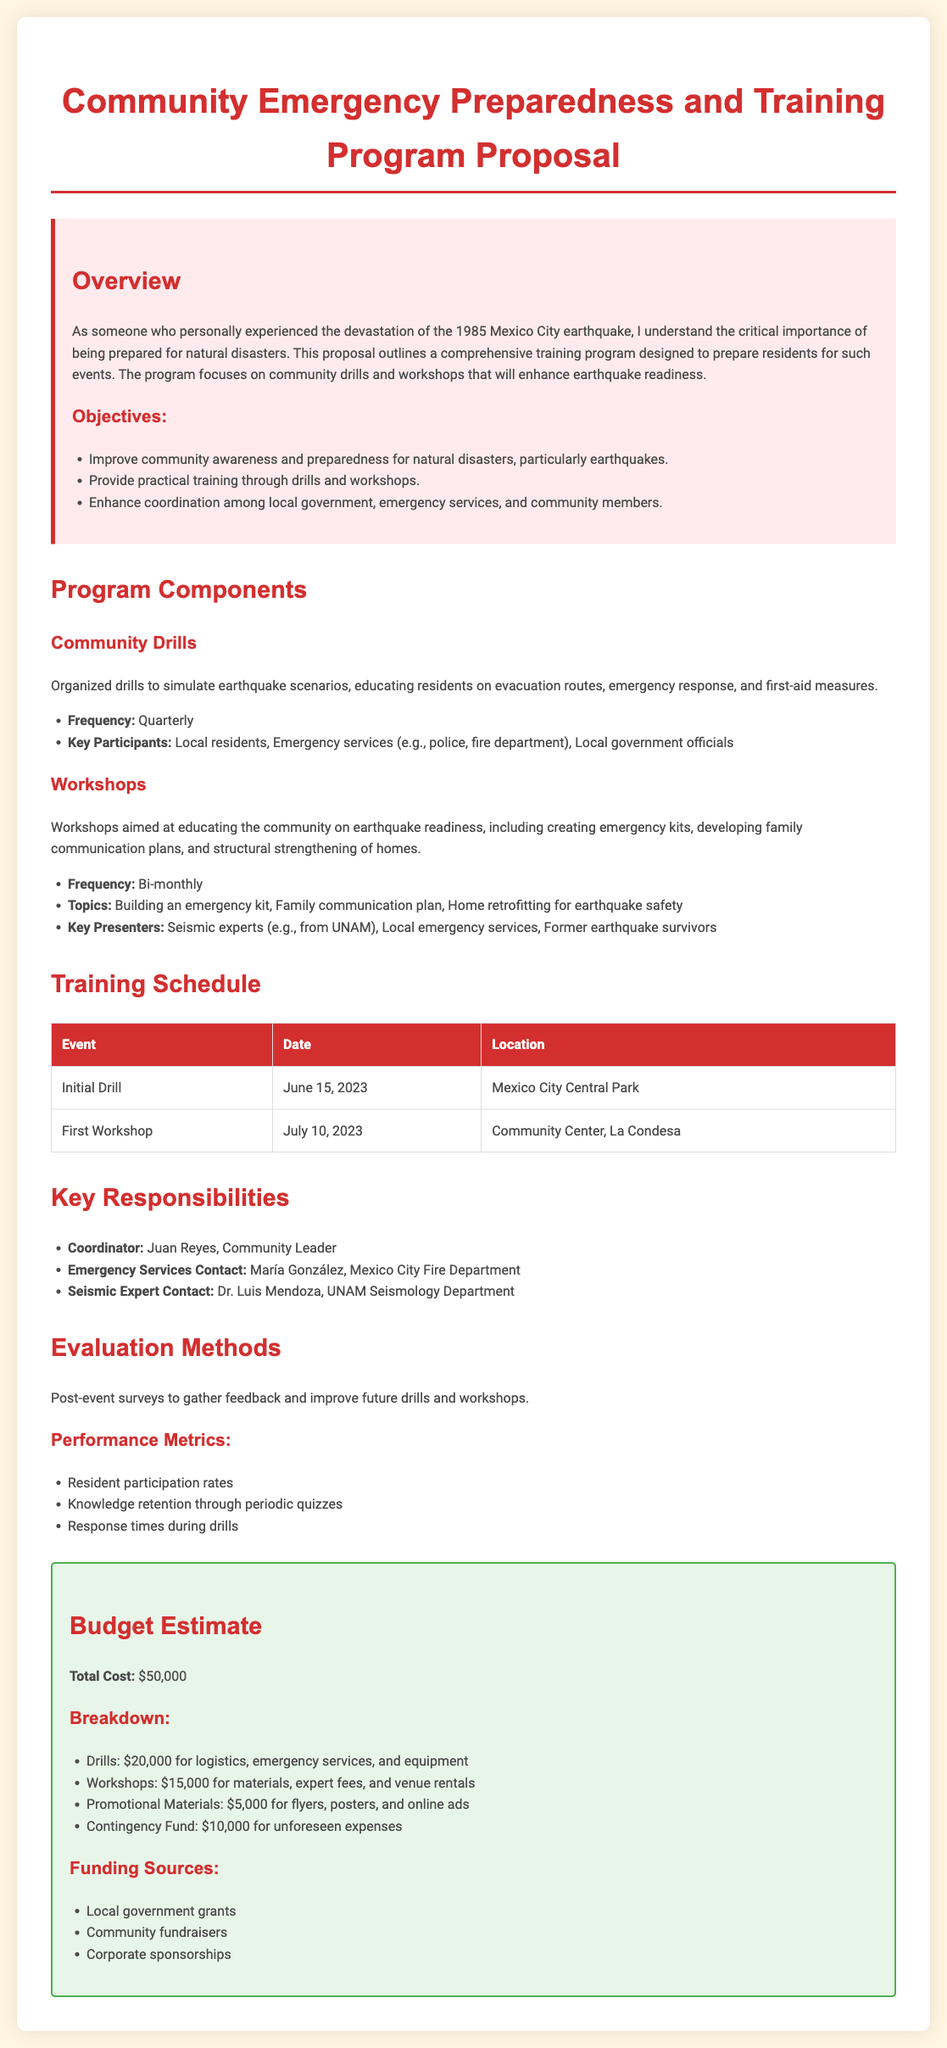What is the total cost of the program? The total cost is outlined in the budget section of the document and is listed as $50,000.
Answer: $50,000 Who is the coordinator of the program? The coordinator is mentioned in the key responsibilities section, and the name provided is Juan Reyes.
Answer: Juan Reyes When is the initial drill scheduled? The date for the initial drill is specified in the training schedule table as June 15, 2023.
Answer: June 15, 2023 What is one of the key topics covered in the workshops? The workshop topics are listed, and one of them is building an emergency kit.
Answer: Building an emergency kit How often will the community drills occur? The frequency of community drills is mentioned and specified as quarterly.
Answer: Quarterly What evaluation method will be used to improve future events? The evaluation methods include post-event surveys, as stated in the evaluation methods section.
Answer: Post-event surveys Which organization is providing a seismic expert? The document states that the seismic expert is from UNAM, which is the National Autonomous University of Mexico.
Answer: UNAM How many key presentors will be involved in the workshops? The key presenters listed include three different types of presenters: seismic experts, local emergency services, and former earthquake survivors.
Answer: Three What is the funding source mentioned in the budget? One of the funding sources listed is local government grants which will help support the program financially.
Answer: Local government grants 